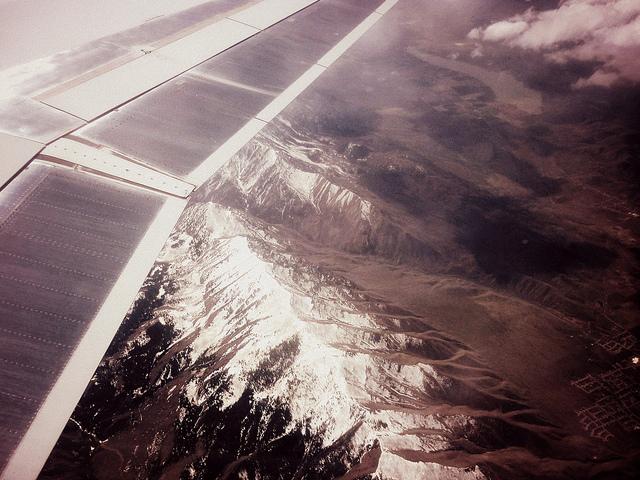Do you see a part of a plane anywhere in this picture?
Concise answer only. Yes. How many clouds can be seen?
Short answer required. 1. Was this taken from a boat?
Keep it brief. No. What is this used for?
Answer briefly. Flying. 